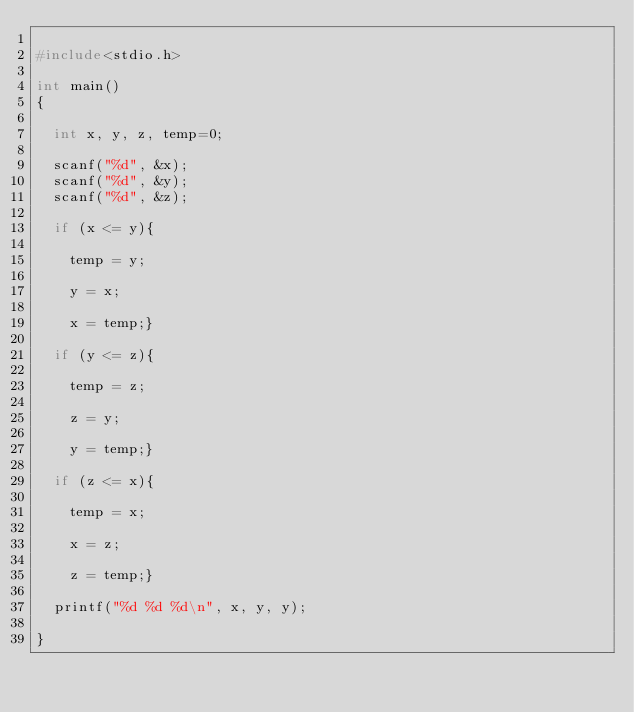Convert code to text. <code><loc_0><loc_0><loc_500><loc_500><_C_>
#include<stdio.h>

int main()
{

	int x, y, z, temp=0;

	scanf("%d", &x);
	scanf("%d", &y);
	scanf("%d", &z);

	if (x <= y){

		temp = y;

		y = x;

		x = temp;}

	if (y <= z){

		temp = z;

		z = y;

		y = temp;}

	if (z <= x){

		temp = x;

		x = z;

		z = temp;}

	printf("%d %d %d\n", x, y, y);

}</code> 